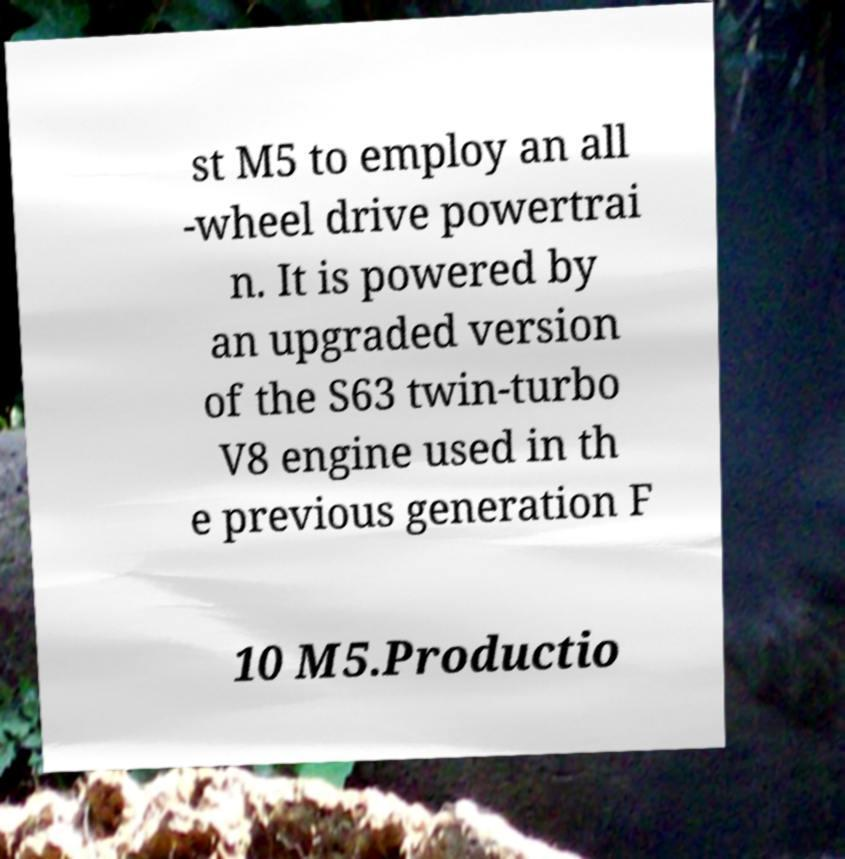Please identify and transcribe the text found in this image. st M5 to employ an all -wheel drive powertrai n. It is powered by an upgraded version of the S63 twin-turbo V8 engine used in th e previous generation F 10 M5.Productio 